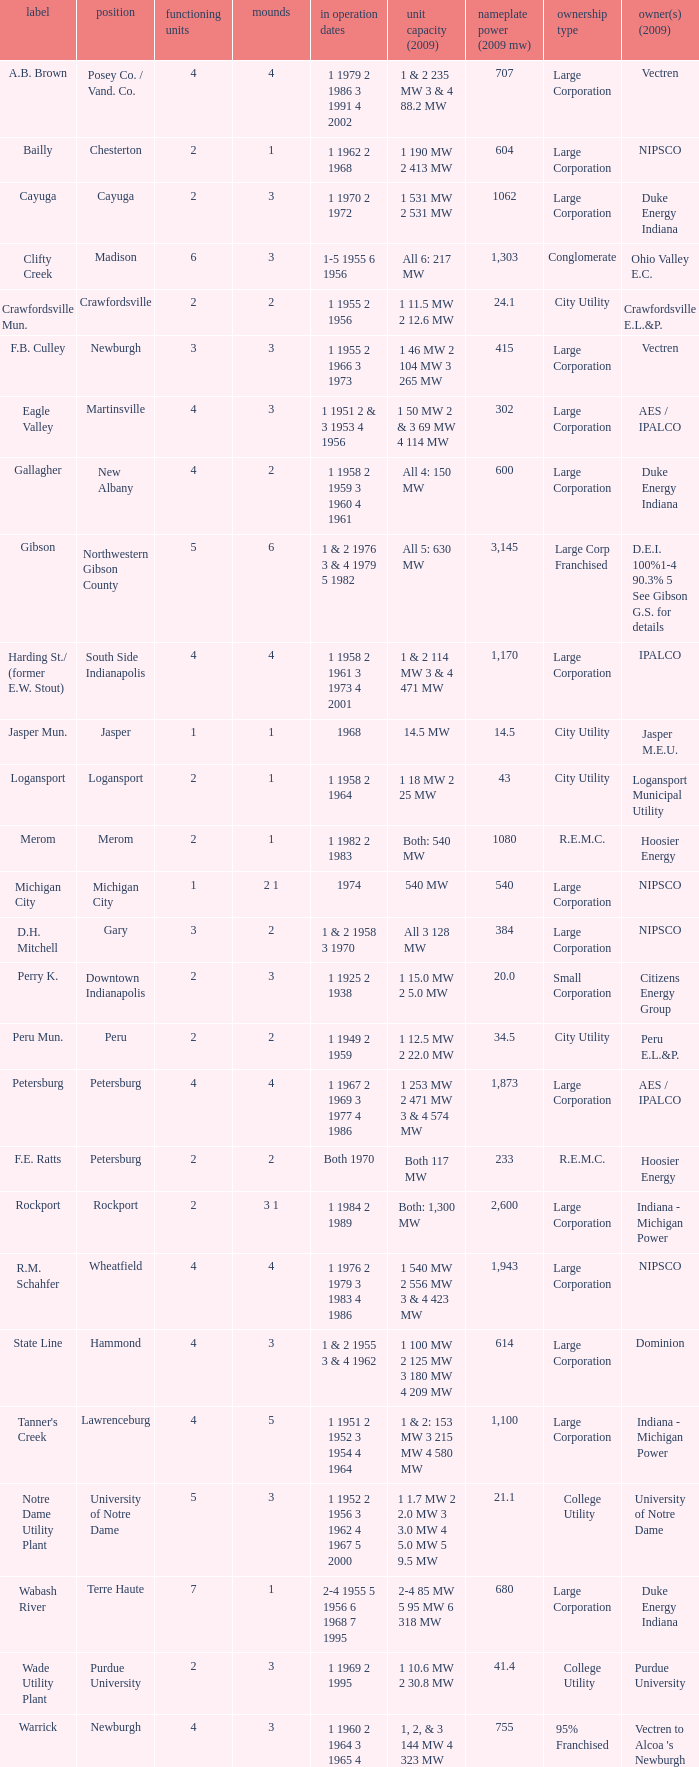Name the stacks for 1 1969 2 1995 3.0. 